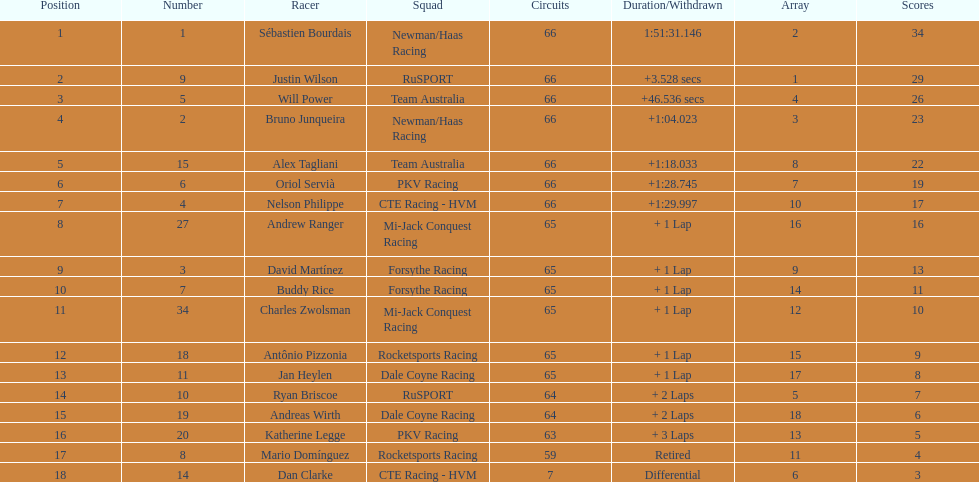Which country had more drivers representing them, the us or germany? Tie. 